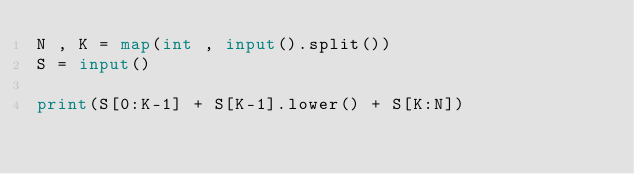<code> <loc_0><loc_0><loc_500><loc_500><_Python_>N , K = map(int , input().split())
S = input()

print(S[0:K-1] + S[K-1].lower() + S[K:N])</code> 